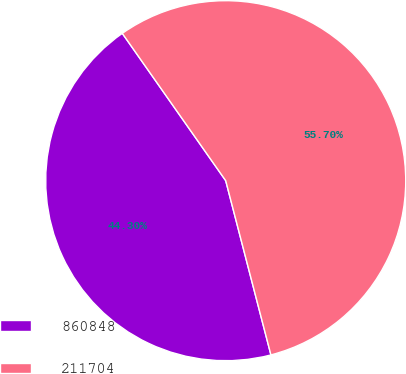<chart> <loc_0><loc_0><loc_500><loc_500><pie_chart><fcel>860848<fcel>211704<nl><fcel>44.3%<fcel>55.7%<nl></chart> 